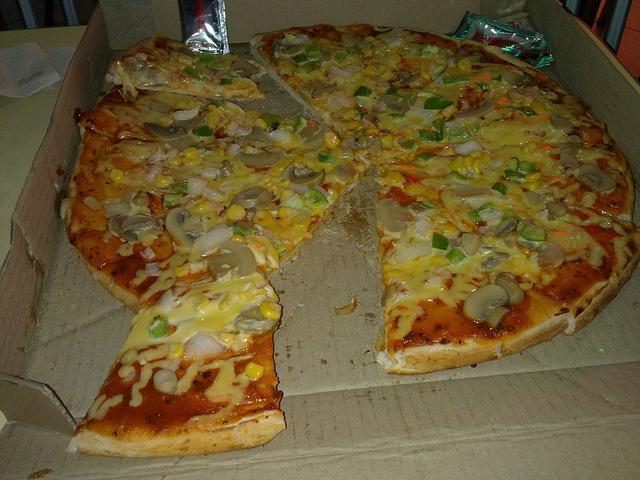What vegetable is the unusual one on the pizza?
Select the correct answer and articulate reasoning with the following format: 'Answer: answer
Rationale: rationale.'
Options: Onions, green pepper, mushrooms, corn. Answer: corn.
Rationale: Normally corn is not on pizza. 